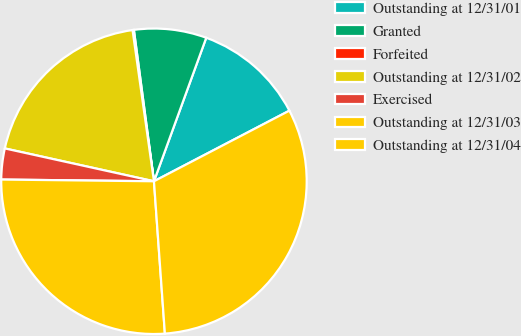Convert chart to OTSL. <chart><loc_0><loc_0><loc_500><loc_500><pie_chart><fcel>Outstanding at 12/31/01<fcel>Granted<fcel>Forfeited<fcel>Outstanding at 12/31/02<fcel>Exercised<fcel>Outstanding at 12/31/03<fcel>Outstanding at 12/31/04<nl><fcel>11.79%<fcel>7.66%<fcel>0.14%<fcel>19.31%<fcel>3.27%<fcel>26.32%<fcel>31.51%<nl></chart> 